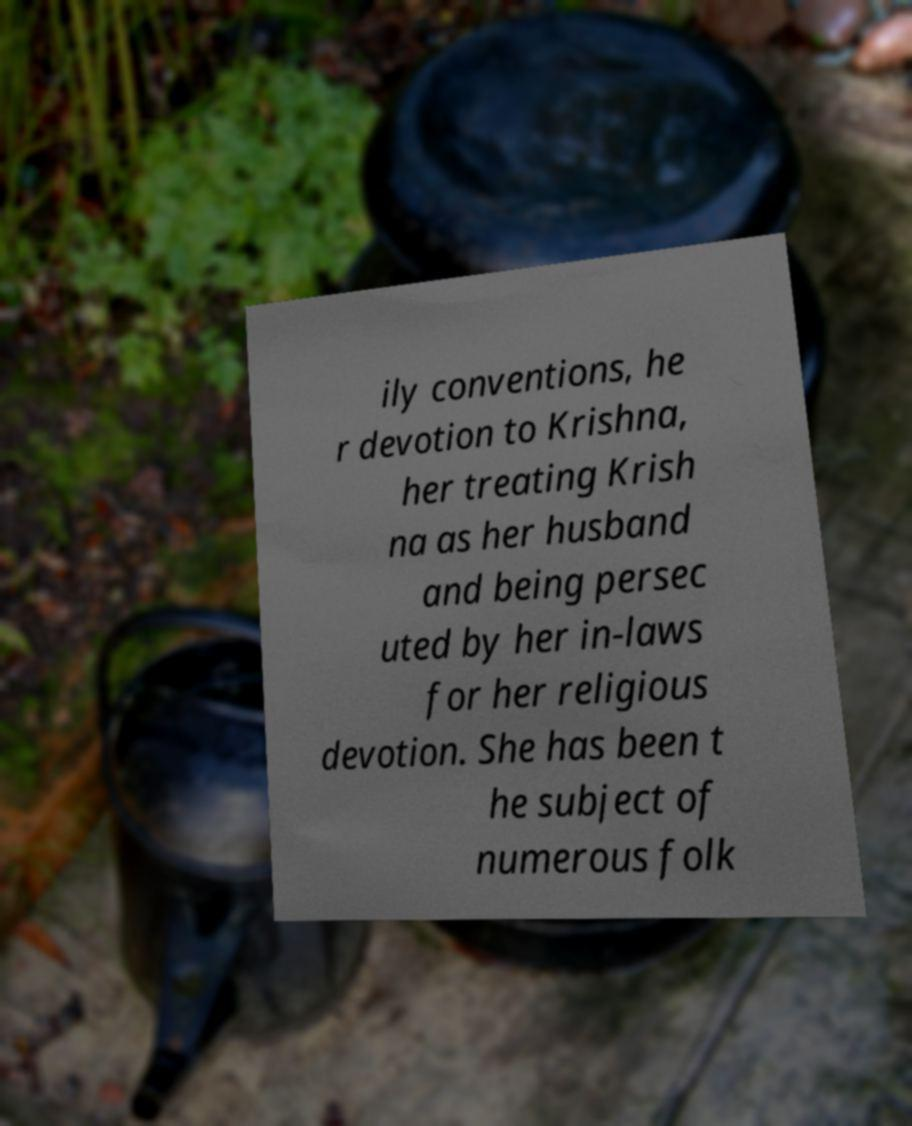For documentation purposes, I need the text within this image transcribed. Could you provide that? ily conventions, he r devotion to Krishna, her treating Krish na as her husband and being persec uted by her in-laws for her religious devotion. She has been t he subject of numerous folk 